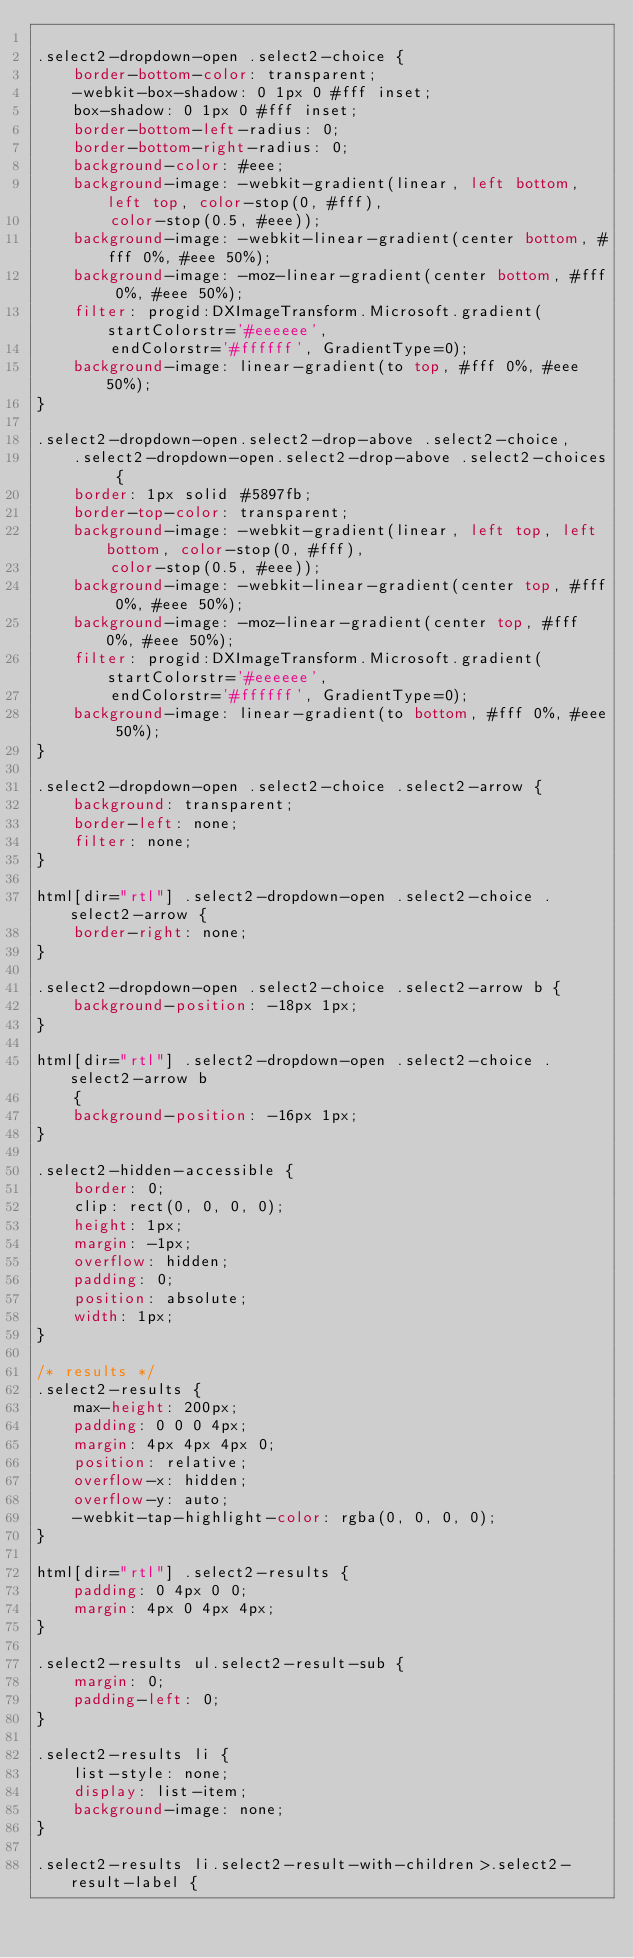<code> <loc_0><loc_0><loc_500><loc_500><_CSS_>
.select2-dropdown-open .select2-choice {
	border-bottom-color: transparent;
	-webkit-box-shadow: 0 1px 0 #fff inset;
	box-shadow: 0 1px 0 #fff inset;
	border-bottom-left-radius: 0;
	border-bottom-right-radius: 0;
	background-color: #eee;
	background-image: -webkit-gradient(linear, left bottom, left top, color-stop(0, #fff),
		color-stop(0.5, #eee));
	background-image: -webkit-linear-gradient(center bottom, #fff 0%, #eee 50%);
	background-image: -moz-linear-gradient(center bottom, #fff 0%, #eee 50%);
	filter: progid:DXImageTransform.Microsoft.gradient(startColorstr='#eeeeee',
		endColorstr='#ffffff', GradientType=0);
	background-image: linear-gradient(to top, #fff 0%, #eee 50%);
}

.select2-dropdown-open.select2-drop-above .select2-choice,
	.select2-dropdown-open.select2-drop-above .select2-choices {
	border: 1px solid #5897fb;
	border-top-color: transparent;
	background-image: -webkit-gradient(linear, left top, left bottom, color-stop(0, #fff),
		color-stop(0.5, #eee));
	background-image: -webkit-linear-gradient(center top, #fff 0%, #eee 50%);
	background-image: -moz-linear-gradient(center top, #fff 0%, #eee 50%);
	filter: progid:DXImageTransform.Microsoft.gradient(startColorstr='#eeeeee',
		endColorstr='#ffffff', GradientType=0);
	background-image: linear-gradient(to bottom, #fff 0%, #eee 50%);
}

.select2-dropdown-open .select2-choice .select2-arrow {
	background: transparent;
	border-left: none;
	filter: none;
}

html[dir="rtl"] .select2-dropdown-open .select2-choice .select2-arrow {
	border-right: none;
}

.select2-dropdown-open .select2-choice .select2-arrow b {
	background-position: -18px 1px;
}

html[dir="rtl"] .select2-dropdown-open .select2-choice .select2-arrow b
	{
	background-position: -16px 1px;
}

.select2-hidden-accessible {
	border: 0;
	clip: rect(0, 0, 0, 0);
	height: 1px;
	margin: -1px;
	overflow: hidden;
	padding: 0;
	position: absolute;
	width: 1px;
}

/* results */
.select2-results {
	max-height: 200px;
	padding: 0 0 0 4px;
	margin: 4px 4px 4px 0;
	position: relative;
	overflow-x: hidden;
	overflow-y: auto;
	-webkit-tap-highlight-color: rgba(0, 0, 0, 0);
}

html[dir="rtl"] .select2-results {
	padding: 0 4px 0 0;
	margin: 4px 0 4px 4px;
}

.select2-results ul.select2-result-sub {
	margin: 0;
	padding-left: 0;
}

.select2-results li {
	list-style: none;
	display: list-item;
	background-image: none;
}

.select2-results li.select2-result-with-children>.select2-result-label {</code> 